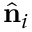<formula> <loc_0><loc_0><loc_500><loc_500>\hat { n } _ { i }</formula> 